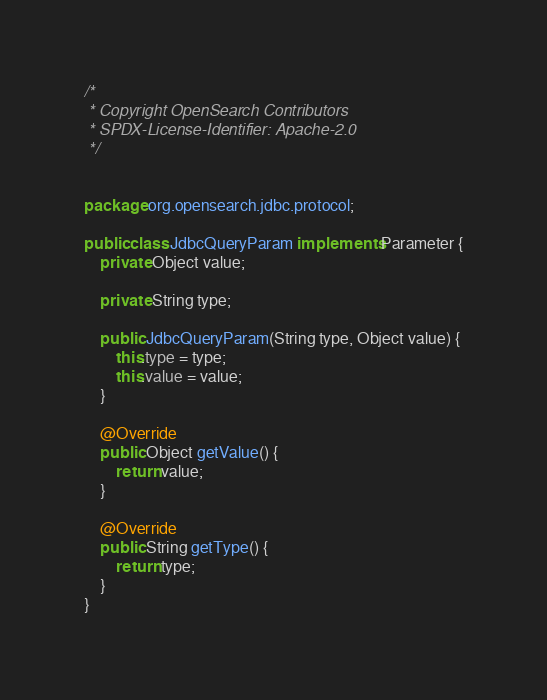<code> <loc_0><loc_0><loc_500><loc_500><_Java_>/*
 * Copyright OpenSearch Contributors
 * SPDX-License-Identifier: Apache-2.0
 */


package org.opensearch.jdbc.protocol;

public class JdbcQueryParam implements Parameter {
    private Object value;

    private String type;

    public JdbcQueryParam(String type, Object value) {
        this.type = type;
        this.value = value;
    }

    @Override
    public Object getValue() {
        return value;
    }

    @Override
    public String getType() {
        return type;
    }
}
</code> 